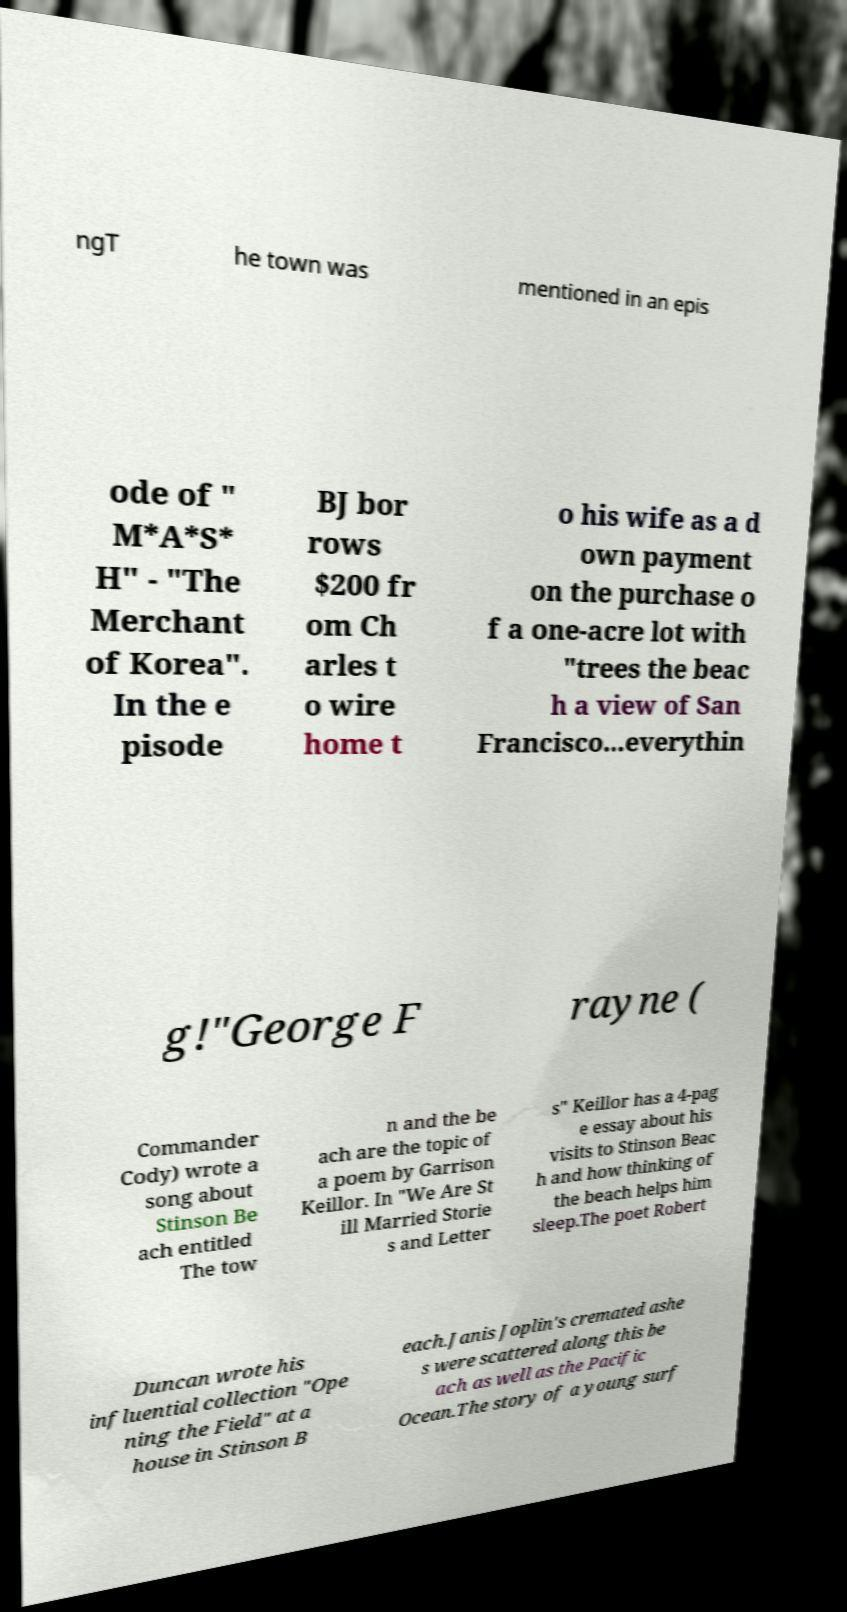There's text embedded in this image that I need extracted. Can you transcribe it verbatim? ngT he town was mentioned in an epis ode of " M*A*S* H" - "The Merchant of Korea". In the e pisode BJ bor rows $200 fr om Ch arles t o wire home t o his wife as a d own payment on the purchase o f a one-acre lot with "trees the beac h a view of San Francisco...everythin g!"George F rayne ( Commander Cody) wrote a song about Stinson Be ach entitled The tow n and the be ach are the topic of a poem by Garrison Keillor. In "We Are St ill Married Storie s and Letter s" Keillor has a 4-pag e essay about his visits to Stinson Beac h and how thinking of the beach helps him sleep.The poet Robert Duncan wrote his influential collection "Ope ning the Field" at a house in Stinson B each.Janis Joplin's cremated ashe s were scattered along this be ach as well as the Pacific Ocean.The story of a young surf 